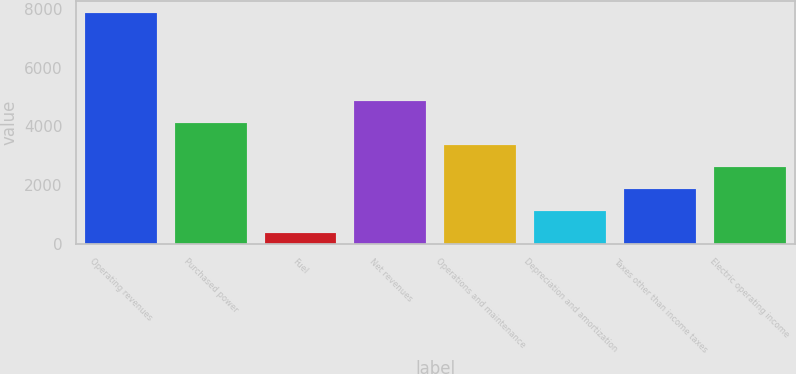Convert chart to OTSL. <chart><loc_0><loc_0><loc_500><loc_500><bar_chart><fcel>Operating revenues<fcel>Purchased power<fcel>Fuel<fcel>Net revenues<fcel>Operations and maintenance<fcel>Depreciation and amortization<fcel>Taxes other than income taxes<fcel>Electric operating income<nl><fcel>7878<fcel>4127<fcel>376<fcel>4877.2<fcel>3376.8<fcel>1126.2<fcel>1876.4<fcel>2626.6<nl></chart> 